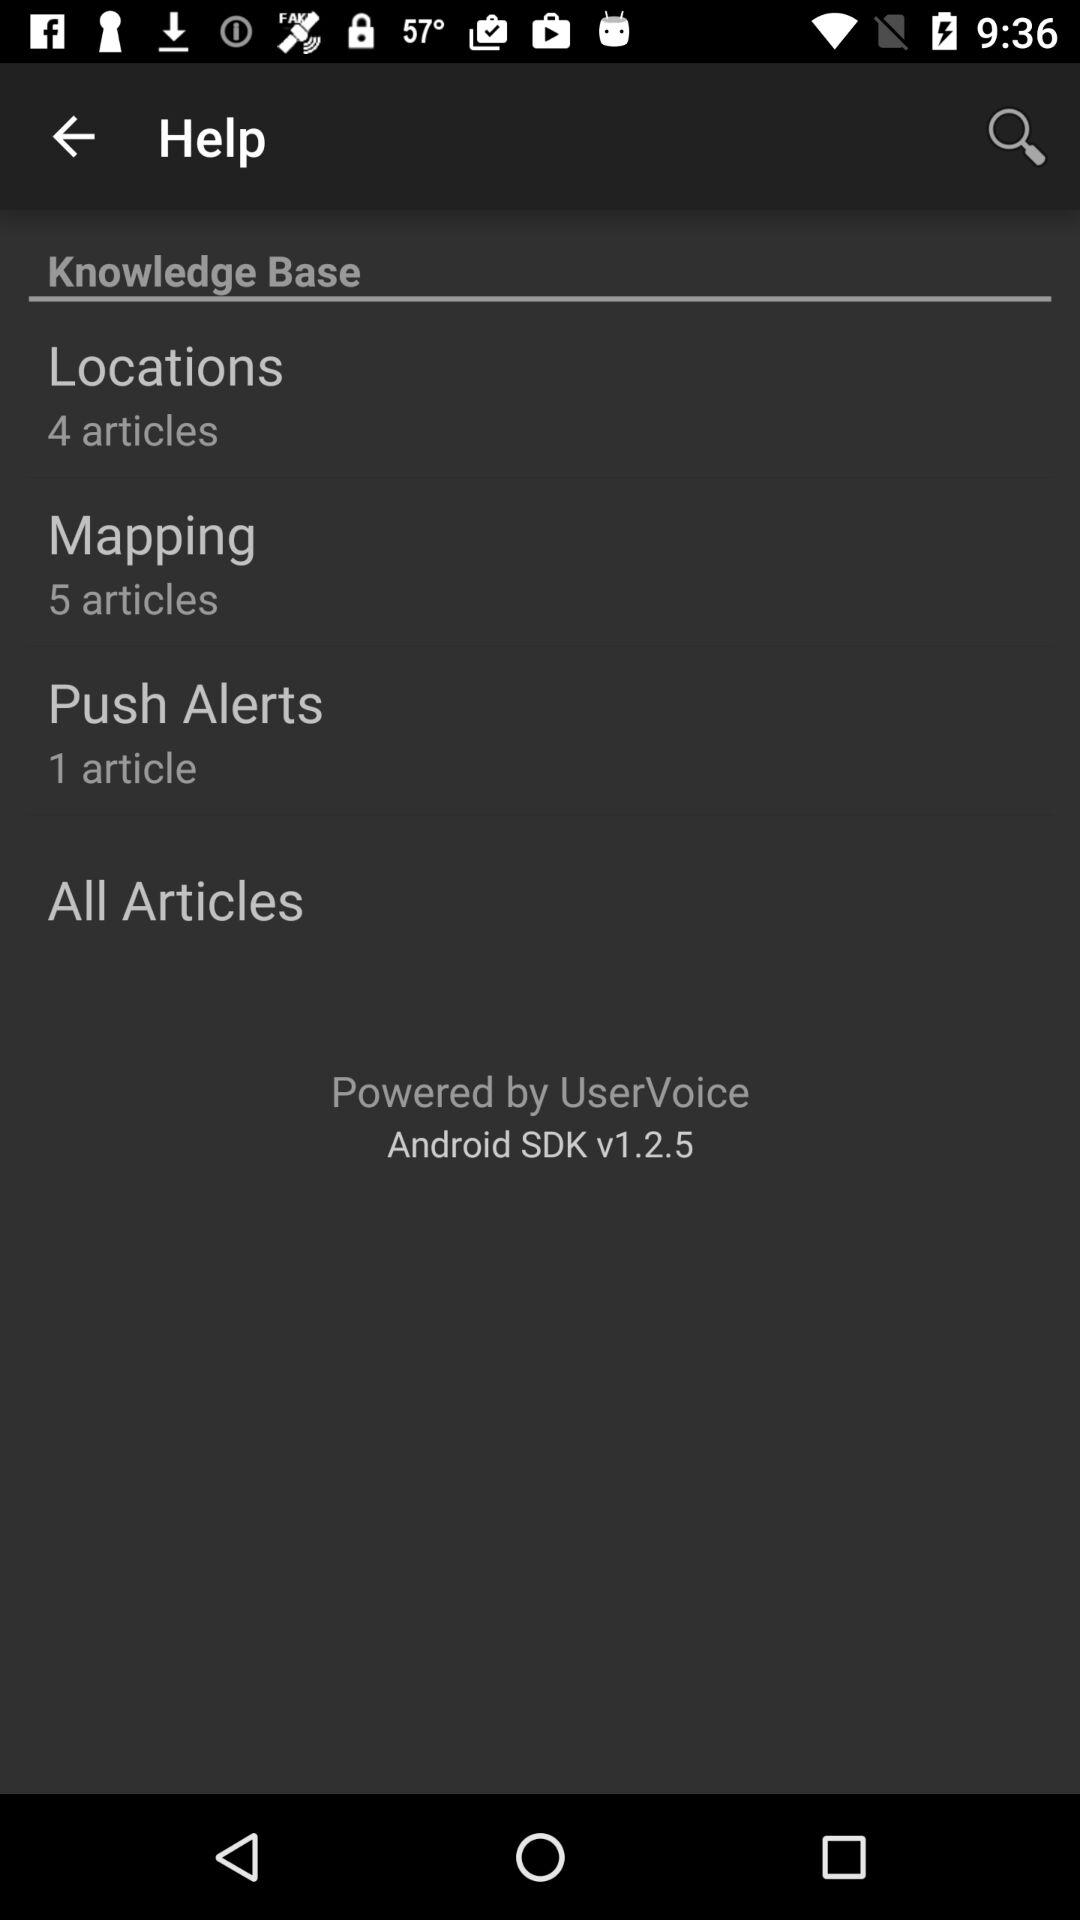How many articles are present in the locations? There are 4 articles present. 